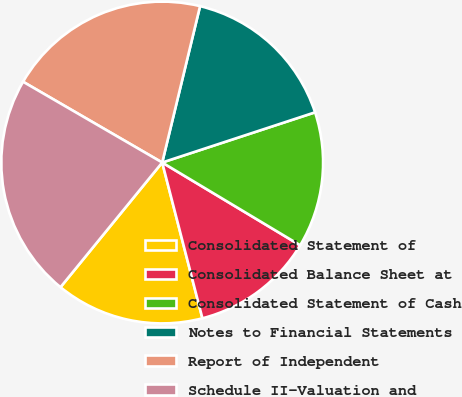<chart> <loc_0><loc_0><loc_500><loc_500><pie_chart><fcel>Consolidated Statement of<fcel>Consolidated Balance Sheet at<fcel>Consolidated Statement of Cash<fcel>Notes to Financial Statements<fcel>Report of Independent<fcel>Schedule II-Valuation and<nl><fcel>14.91%<fcel>12.38%<fcel>13.65%<fcel>16.17%<fcel>20.41%<fcel>22.48%<nl></chart> 